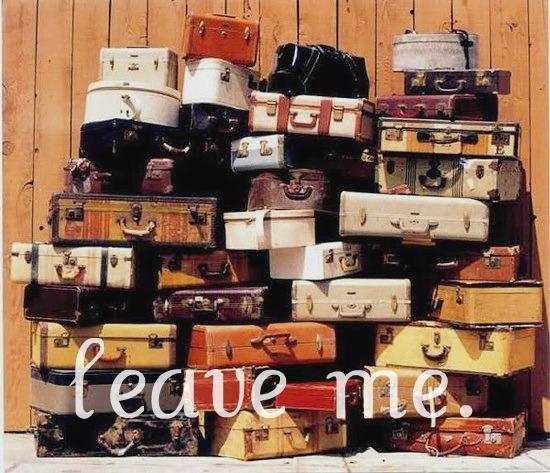What does the caption say?
Give a very brief answer. Leave me. Do people use this object to travel with?
Write a very short answer. Yes. How many suitcases are in this photo?
Keep it brief. 38. 